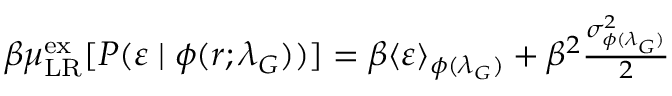Convert formula to latex. <formula><loc_0><loc_0><loc_500><loc_500>\begin{array} { r } { \beta \mu _ { L R } ^ { e x } [ P ( \varepsilon \, | \, \phi ( r ; \lambda _ { G } ) ) ] = \beta \langle \varepsilon \rangle _ { \phi ( \lambda _ { G } ) } + \beta ^ { 2 } \frac { \sigma _ { \phi ( \lambda _ { G } ) } ^ { 2 } } { 2 } } \end{array}</formula> 